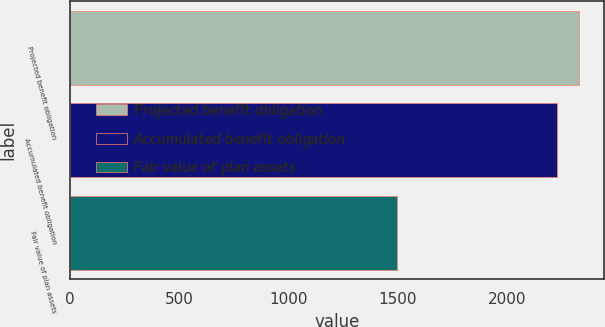Convert chart to OTSL. <chart><loc_0><loc_0><loc_500><loc_500><bar_chart><fcel>Projected benefit obligation<fcel>Accumulated benefit obligation<fcel>Fair value of plan assets<nl><fcel>2329<fcel>2230<fcel>1494<nl></chart> 